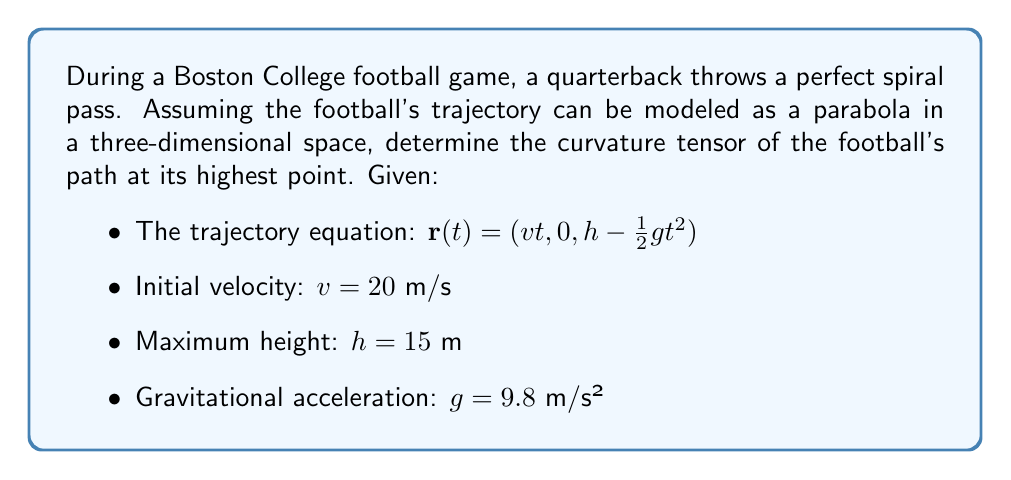Show me your answer to this math problem. To find the curvature tensor of the football's trajectory, we'll follow these steps:

1) First, we need to calculate the first and second derivatives of $\mathbf{r}(t)$:
   $$\mathbf{r}'(t) = (v, 0, -gt)$$
   $$\mathbf{r}''(t) = (0, 0, -g)$$

2) At the highest point, the vertical velocity is zero. We can find this time:
   $$-gt = 0 \implies t = 0$$

3) The metric tensor $g_{ij}$ is the identity matrix in Cartesian coordinates:
   $$g_{ij} = \begin{pmatrix} 1 & 0 & 0 \\ 0 & 1 & 0 \\ 0 & 0 & 1 \end{pmatrix}$$

4) The Christoffel symbols $\Gamma^i_{jk}$ are all zero in Cartesian coordinates.

5) The Riemann curvature tensor $R^i_{jkl}$ is given by:
   $$R^i_{jkl} = \partial_k \Gamma^i_{jl} - \partial_l \Gamma^i_{jk} + \Gamma^i_{mk}\Gamma^m_{jl} - \Gamma^i_{ml}\Gamma^m_{jk}$$

6) Since all Christoffel symbols are zero, the Riemann curvature tensor is also zero:
   $$R^i_{jkl} = 0$$

7) The curvature tensor $K_{ij}$ is related to the Riemann tensor by:
   $$K_{ij} = R^k_{ikj}$$

8) Therefore, the curvature tensor is also zero:
   $$K_{ij} = 0$$

This result indicates that the trajectory of the football, modeled as a parabola in 3D space, has zero intrinsic curvature at its highest point (and indeed at all points) when described in Cartesian coordinates.
Answer: $K_{ij} = 0$ 